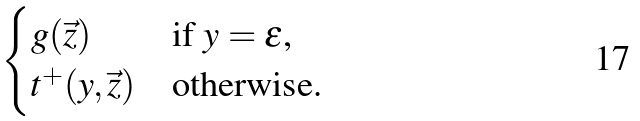<formula> <loc_0><loc_0><loc_500><loc_500>\begin{cases} g ( \vec { z } ) & \text {if $y = \epsilon$,} \\ t ^ { + } ( y , \vec { z } ) & \text {otherwise.} \end{cases}</formula> 